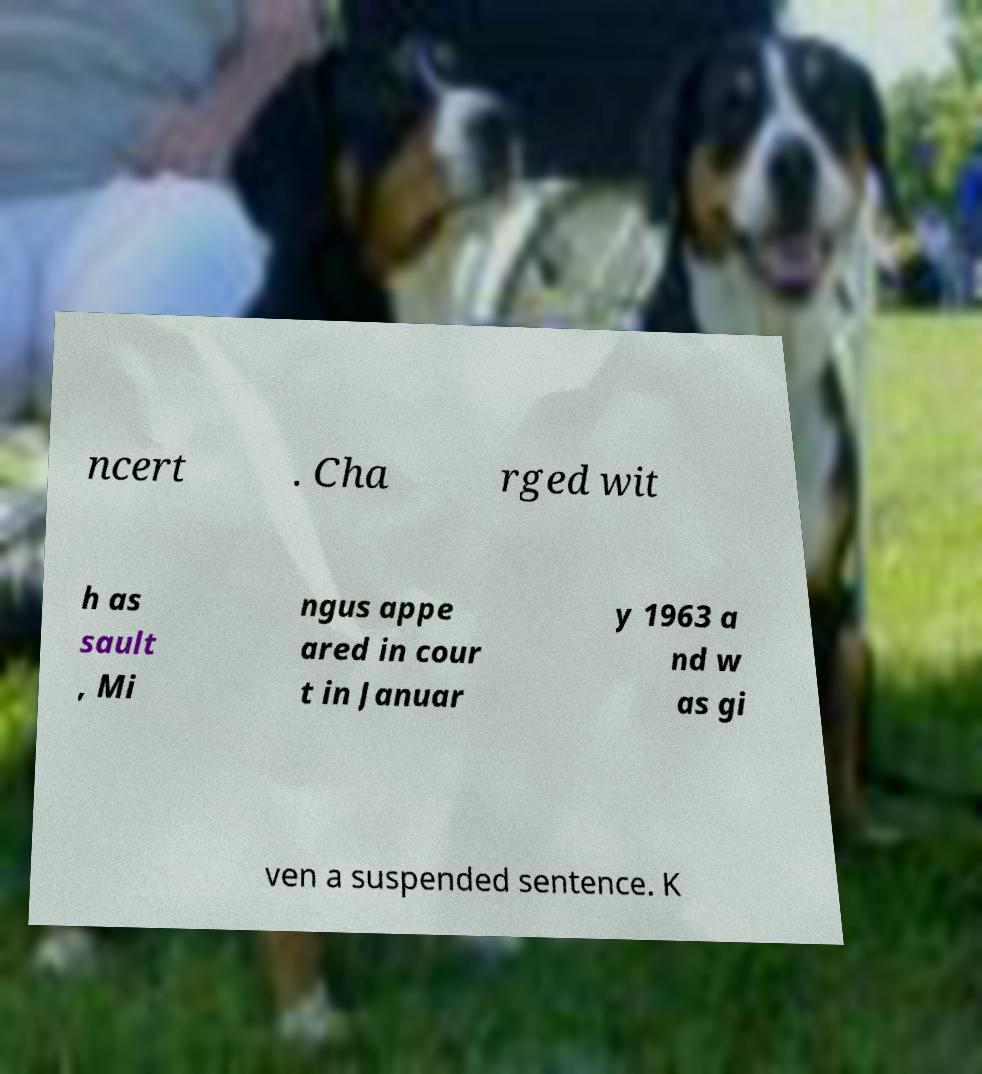Please read and relay the text visible in this image. What does it say? ncert . Cha rged wit h as sault , Mi ngus appe ared in cour t in Januar y 1963 a nd w as gi ven a suspended sentence. K 